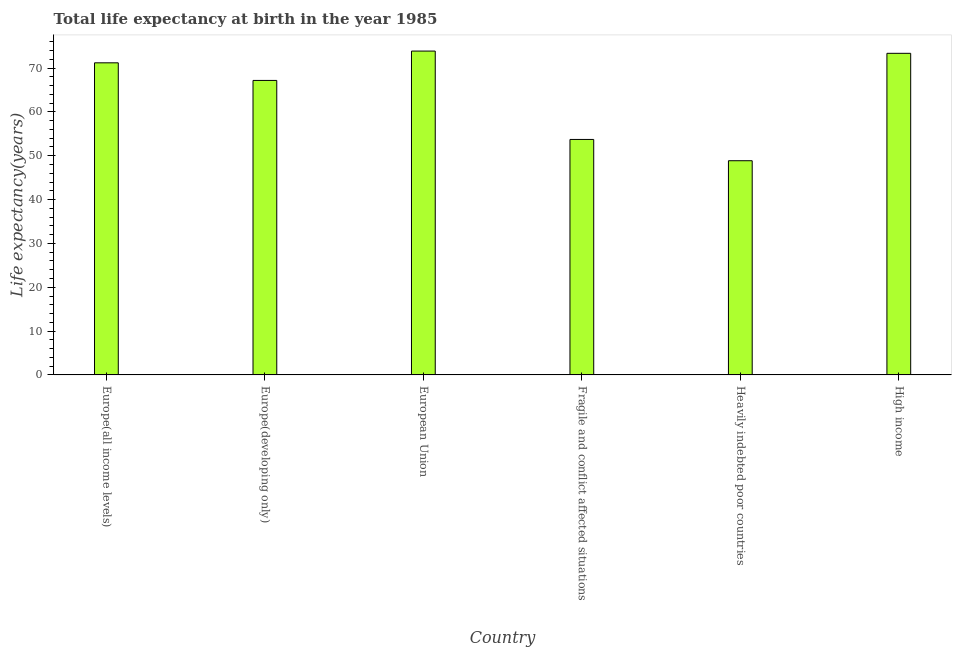Does the graph contain any zero values?
Provide a short and direct response. No. Does the graph contain grids?
Offer a terse response. No. What is the title of the graph?
Your answer should be compact. Total life expectancy at birth in the year 1985. What is the label or title of the X-axis?
Provide a succinct answer. Country. What is the label or title of the Y-axis?
Your response must be concise. Life expectancy(years). What is the life expectancy at birth in European Union?
Your answer should be very brief. 73.88. Across all countries, what is the maximum life expectancy at birth?
Provide a short and direct response. 73.88. Across all countries, what is the minimum life expectancy at birth?
Provide a short and direct response. 48.86. In which country was the life expectancy at birth minimum?
Give a very brief answer. Heavily indebted poor countries. What is the sum of the life expectancy at birth?
Make the answer very short. 388.19. What is the difference between the life expectancy at birth in Heavily indebted poor countries and High income?
Provide a succinct answer. -24.5. What is the average life expectancy at birth per country?
Make the answer very short. 64.7. What is the median life expectancy at birth?
Your response must be concise. 69.19. In how many countries, is the life expectancy at birth greater than 16 years?
Your answer should be compact. 6. What is the ratio of the life expectancy at birth in Europe(all income levels) to that in High income?
Offer a very short reply. 0.97. Is the difference between the life expectancy at birth in Heavily indebted poor countries and High income greater than the difference between any two countries?
Your answer should be compact. No. What is the difference between the highest and the second highest life expectancy at birth?
Keep it short and to the point. 0.51. Is the sum of the life expectancy at birth in Europe(all income levels) and Heavily indebted poor countries greater than the maximum life expectancy at birth across all countries?
Make the answer very short. Yes. What is the difference between the highest and the lowest life expectancy at birth?
Your response must be concise. 25.02. In how many countries, is the life expectancy at birth greater than the average life expectancy at birth taken over all countries?
Your response must be concise. 4. How many bars are there?
Make the answer very short. 6. How many countries are there in the graph?
Your answer should be very brief. 6. What is the difference between two consecutive major ticks on the Y-axis?
Your answer should be compact. 10. Are the values on the major ticks of Y-axis written in scientific E-notation?
Your answer should be compact. No. What is the Life expectancy(years) in Europe(all income levels)?
Your response must be concise. 71.2. What is the Life expectancy(years) in Europe(developing only)?
Provide a succinct answer. 67.18. What is the Life expectancy(years) in European Union?
Offer a very short reply. 73.88. What is the Life expectancy(years) in Fragile and conflict affected situations?
Your answer should be compact. 53.71. What is the Life expectancy(years) of Heavily indebted poor countries?
Keep it short and to the point. 48.86. What is the Life expectancy(years) in High income?
Make the answer very short. 73.36. What is the difference between the Life expectancy(years) in Europe(all income levels) and Europe(developing only)?
Make the answer very short. 4.02. What is the difference between the Life expectancy(years) in Europe(all income levels) and European Union?
Your answer should be compact. -2.68. What is the difference between the Life expectancy(years) in Europe(all income levels) and Fragile and conflict affected situations?
Make the answer very short. 17.48. What is the difference between the Life expectancy(years) in Europe(all income levels) and Heavily indebted poor countries?
Your response must be concise. 22.33. What is the difference between the Life expectancy(years) in Europe(all income levels) and High income?
Offer a terse response. -2.17. What is the difference between the Life expectancy(years) in Europe(developing only) and European Union?
Your response must be concise. -6.7. What is the difference between the Life expectancy(years) in Europe(developing only) and Fragile and conflict affected situations?
Your answer should be compact. 13.46. What is the difference between the Life expectancy(years) in Europe(developing only) and Heavily indebted poor countries?
Offer a very short reply. 18.32. What is the difference between the Life expectancy(years) in Europe(developing only) and High income?
Your answer should be compact. -6.19. What is the difference between the Life expectancy(years) in European Union and Fragile and conflict affected situations?
Give a very brief answer. 20.16. What is the difference between the Life expectancy(years) in European Union and Heavily indebted poor countries?
Give a very brief answer. 25.02. What is the difference between the Life expectancy(years) in European Union and High income?
Provide a short and direct response. 0.51. What is the difference between the Life expectancy(years) in Fragile and conflict affected situations and Heavily indebted poor countries?
Your answer should be very brief. 4.85. What is the difference between the Life expectancy(years) in Fragile and conflict affected situations and High income?
Give a very brief answer. -19.65. What is the difference between the Life expectancy(years) in Heavily indebted poor countries and High income?
Your answer should be compact. -24.5. What is the ratio of the Life expectancy(years) in Europe(all income levels) to that in Europe(developing only)?
Provide a succinct answer. 1.06. What is the ratio of the Life expectancy(years) in Europe(all income levels) to that in Fragile and conflict affected situations?
Give a very brief answer. 1.32. What is the ratio of the Life expectancy(years) in Europe(all income levels) to that in Heavily indebted poor countries?
Ensure brevity in your answer.  1.46. What is the ratio of the Life expectancy(years) in Europe(developing only) to that in European Union?
Your answer should be compact. 0.91. What is the ratio of the Life expectancy(years) in Europe(developing only) to that in Fragile and conflict affected situations?
Keep it short and to the point. 1.25. What is the ratio of the Life expectancy(years) in Europe(developing only) to that in Heavily indebted poor countries?
Give a very brief answer. 1.38. What is the ratio of the Life expectancy(years) in Europe(developing only) to that in High income?
Your response must be concise. 0.92. What is the ratio of the Life expectancy(years) in European Union to that in Fragile and conflict affected situations?
Make the answer very short. 1.38. What is the ratio of the Life expectancy(years) in European Union to that in Heavily indebted poor countries?
Give a very brief answer. 1.51. What is the ratio of the Life expectancy(years) in European Union to that in High income?
Your answer should be compact. 1.01. What is the ratio of the Life expectancy(years) in Fragile and conflict affected situations to that in Heavily indebted poor countries?
Ensure brevity in your answer.  1.1. What is the ratio of the Life expectancy(years) in Fragile and conflict affected situations to that in High income?
Offer a terse response. 0.73. What is the ratio of the Life expectancy(years) in Heavily indebted poor countries to that in High income?
Offer a terse response. 0.67. 